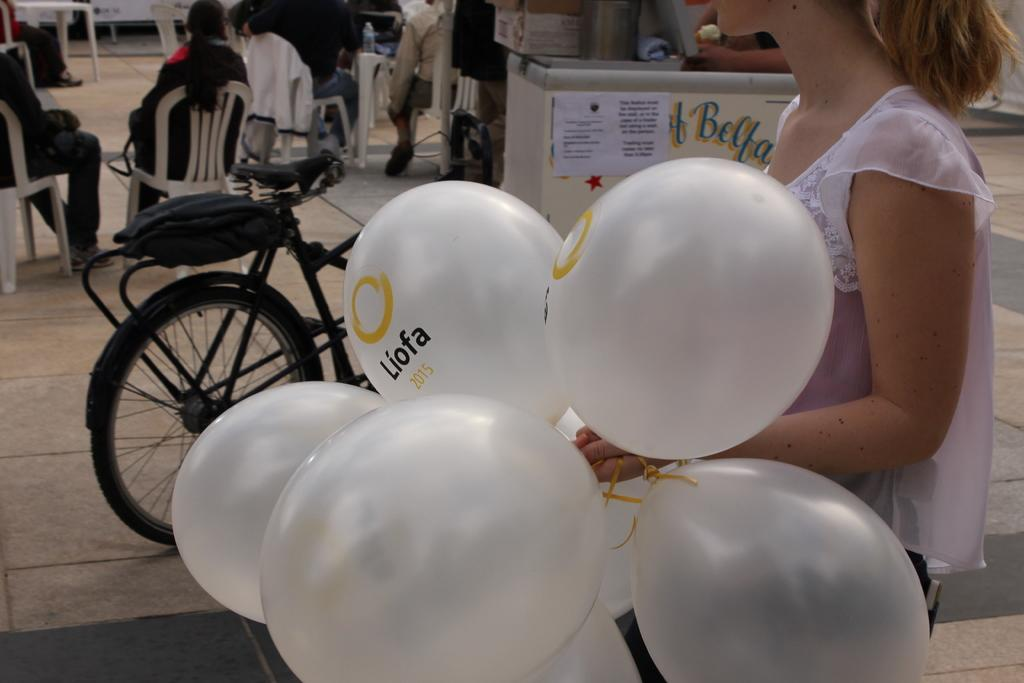Who is the main subject in the image? There is a woman in the image. What is the woman doing in the image? The woman is walking in the image. What is the woman holding in the image? The woman is holding balloons in the image. What can be seen in the background of the image? There are people sitting in chairs in the background of the image. What is the value of the creature attending the event in the image? There is no creature or event present in the image. 